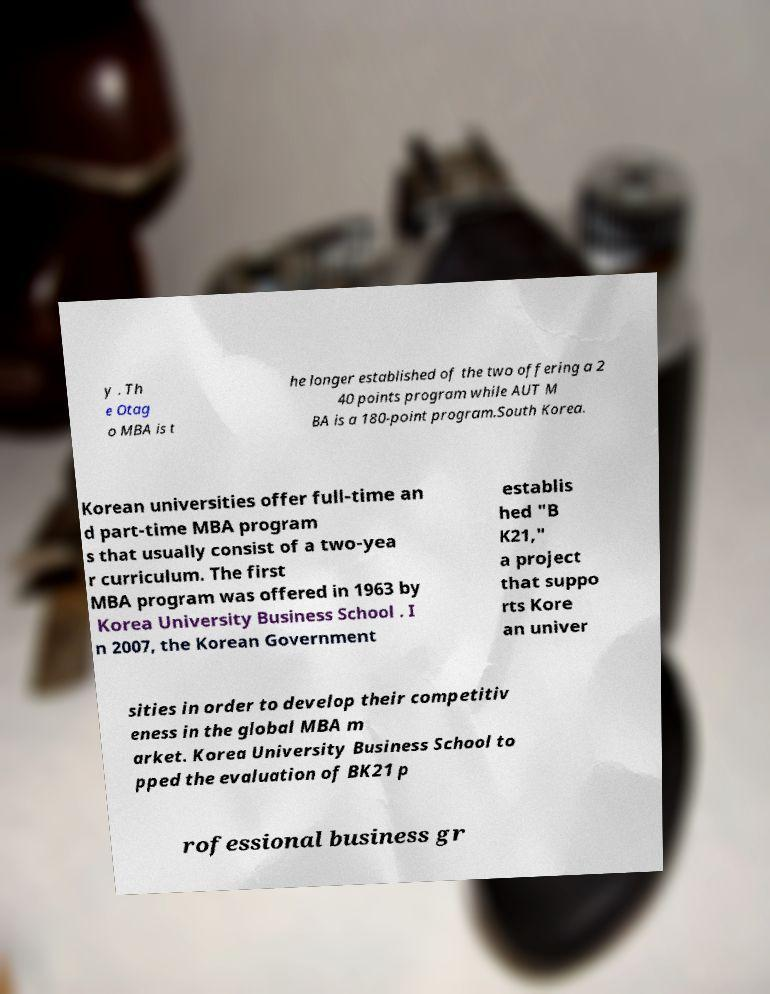For documentation purposes, I need the text within this image transcribed. Could you provide that? y . Th e Otag o MBA is t he longer established of the two offering a 2 40 points program while AUT M BA is a 180-point program.South Korea. Korean universities offer full-time an d part-time MBA program s that usually consist of a two-yea r curriculum. The first MBA program was offered in 1963 by Korea University Business School . I n 2007, the Korean Government establis hed "B K21," a project that suppo rts Kore an univer sities in order to develop their competitiv eness in the global MBA m arket. Korea University Business School to pped the evaluation of BK21 p rofessional business gr 